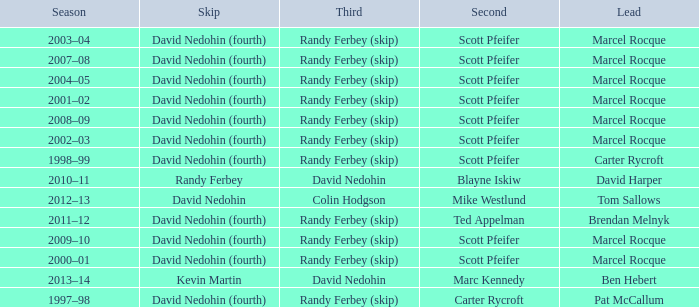Which Season has a Third of colin hodgson? 2012–13. 